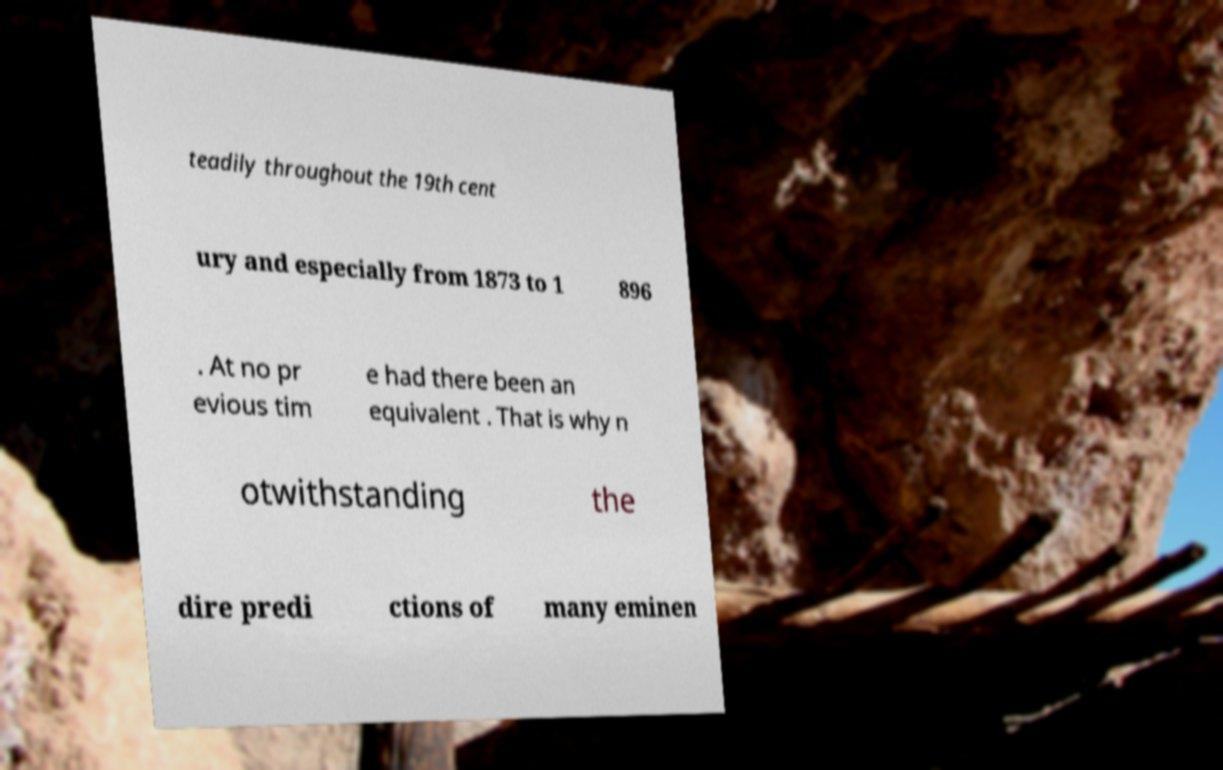What messages or text are displayed in this image? I need them in a readable, typed format. teadily throughout the 19th cent ury and especially from 1873 to 1 896 . At no pr evious tim e had there been an equivalent . That is why n otwithstanding the dire predi ctions of many eminen 